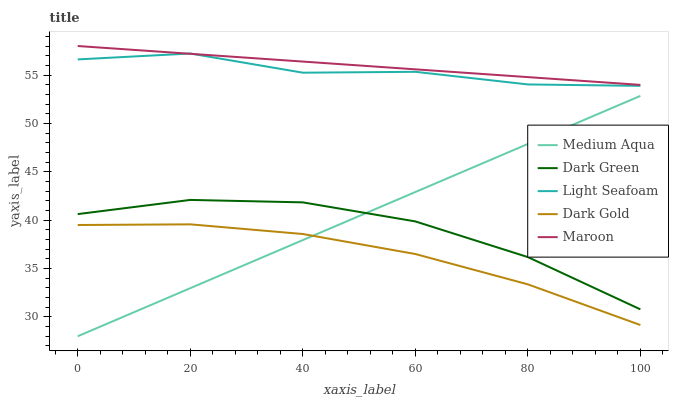Does Medium Aqua have the minimum area under the curve?
Answer yes or no. No. Does Medium Aqua have the maximum area under the curve?
Answer yes or no. No. Is Medium Aqua the smoothest?
Answer yes or no. No. Is Medium Aqua the roughest?
Answer yes or no. No. Does Maroon have the lowest value?
Answer yes or no. No. Does Medium Aqua have the highest value?
Answer yes or no. No. Is Dark Green less than Light Seafoam?
Answer yes or no. Yes. Is Maroon greater than Dark Gold?
Answer yes or no. Yes. Does Dark Green intersect Light Seafoam?
Answer yes or no. No. 